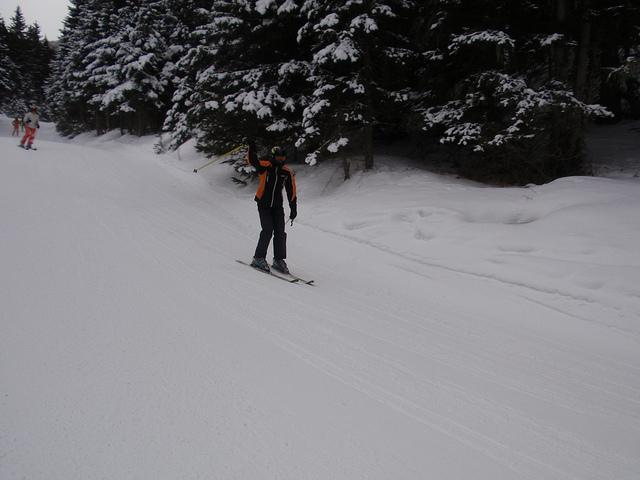Why is the man raising his arm while skiing?

Choices:
A) getting help
B) climbing
C) claiming victory
D) doing tricks claiming victory 